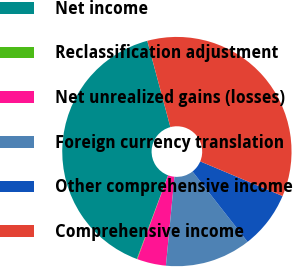Convert chart. <chart><loc_0><loc_0><loc_500><loc_500><pie_chart><fcel>Net income<fcel>Reclassification adjustment<fcel>Net unrealized gains (losses)<fcel>Foreign currency translation<fcel>Other comprehensive income<fcel>Comprehensive income<nl><fcel>40.17%<fcel>0.07%<fcel>4.08%<fcel>12.1%<fcel>8.09%<fcel>35.5%<nl></chart> 